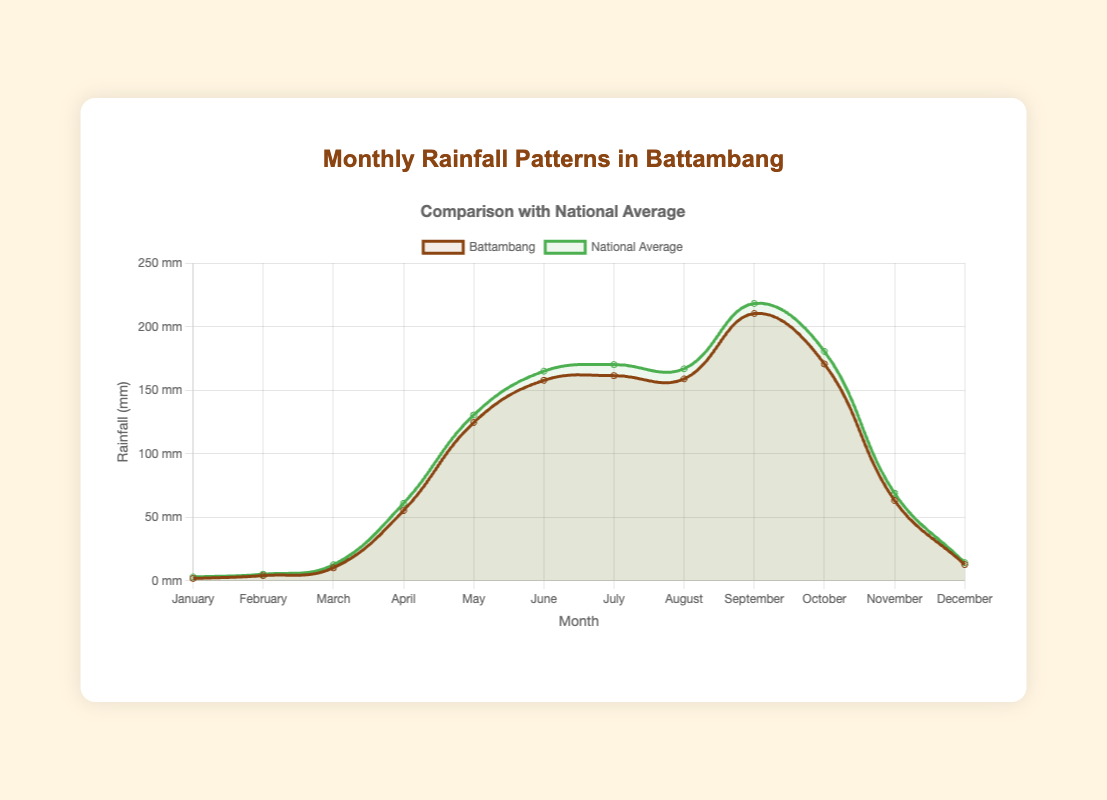How does the rainfall in Battambang in May compare to the National Average for the same month? The rainfall in Battambang in May is 124.6 mm, while the National Average is 130.5 mm. By comparing these two numbers, we see that the National Average is slightly higher than the rainfall in Battambang.
Answer: The National Average is higher During which month does Battambang experience the maximum rainfall, and how does this compare to the National Average for the same month? Battambang experiences the maximum rainfall in September with 210.4 mm. The National Average for September is 218.3 mm. Comparing these, the National Average is higher in the same month.
Answer: September; National Average is higher Identify the months where Battambang's rainfall is greater than the National Average. By comparing the values for each month, we see that Battambang's rainfall is greater than the National Average in February (4.1 > 5.2), July (161.5 > 170.2), and August (158.9 > 166.9).
Answer: None What is the average rainfall for Battambang from June to August? To find the average rainfall from June to August, we sum the values for these months (157.8 + 161.5 + 158.9 = 478.2) and divide by 3. So, the average is 478.2 / 3 = 159.4 mm.
Answer: 159.4 mm How does the comparison of rainfall in Battambang vs. National Average change from January to December? Looking at the data, Battambang generally has less rainfall compared to the National Average in almost all months, except for those peak rainy seasons like February, July, and August where they are closer. Must calculate individual differences and recognize the trend.
Answer: Battambang usually has less rainfall Which month shows the highest increase in rainfall from the previous month in Battambang? The greatest increase is observed by calculating the differences between consecutive months. From March to April, the difference is (55.3 - 10.2 = 45.1 mm), which is considerably larger than other month differences. Thus, April shows the highest increase from March.
Answer: April 